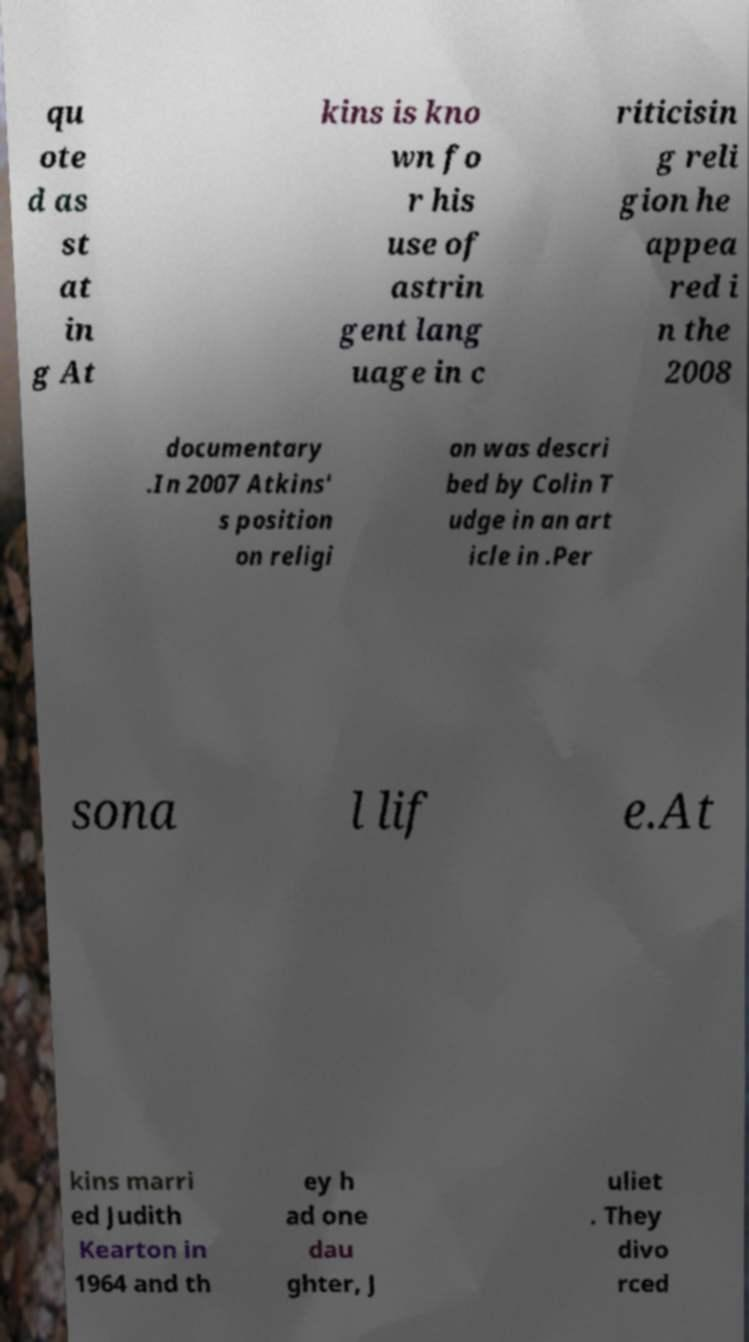Please identify and transcribe the text found in this image. qu ote d as st at in g At kins is kno wn fo r his use of astrin gent lang uage in c riticisin g reli gion he appea red i n the 2008 documentary .In 2007 Atkins' s position on religi on was descri bed by Colin T udge in an art icle in .Per sona l lif e.At kins marri ed Judith Kearton in 1964 and th ey h ad one dau ghter, J uliet . They divo rced 